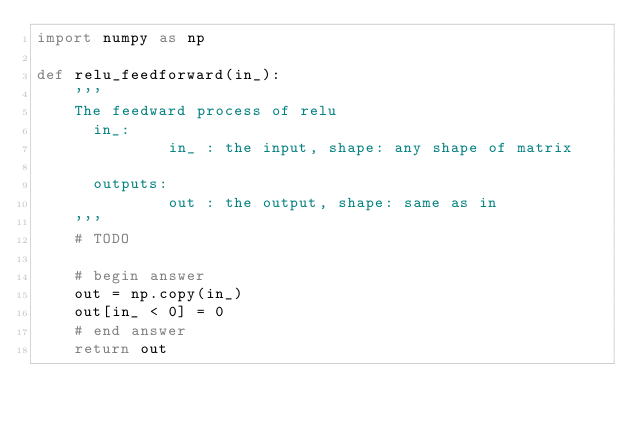<code> <loc_0><loc_0><loc_500><loc_500><_Python_>import numpy as np

def relu_feedforward(in_):
    '''
    The feedward process of relu
      in_:
              in_	: the input, shape: any shape of matrix
      
      outputs:
              out : the output, shape: same as in
    '''
    # TODO

    # begin answer
    out = np.copy(in_)
    out[in_ < 0] = 0
    # end answer
    return out
</code> 